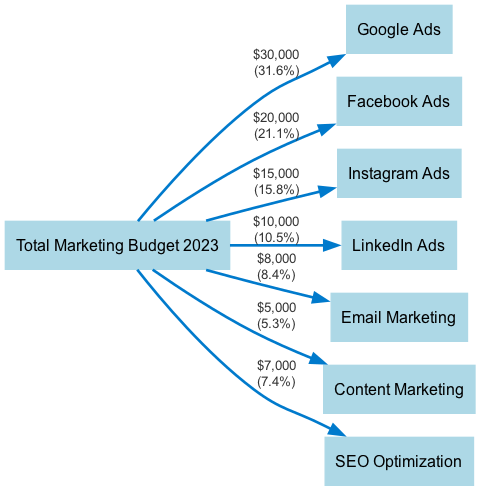What is the total marketing budget for 2023? The diagram indicates the total marketing budget at the source node "Total Marketing Budget 2023." By summing the values of all outgoing links, we find that the total is $100,000.
Answer: $100,000 Which platform receives the highest budget allocation? By examining the outgoing links from "Total Marketing Budget 2023," we see that "Google Ads" has the highest value link of $30,000.
Answer: Google Ads How much is allocated to Email Marketing? The link from "Total Marketing Budget 2023" to "Email Marketing" specifies a value of $8,000.
Answer: $8,000 What percentage of the total budget is allocated to Instagram Ads? The link to "Instagram Ads" shows a value of $15,000. To find the percentage, we calculate (15,000 / 100,000) * 100 = 15%.
Answer: 15% How does the budget for LinkedIn Ads compare to Content Marketing? The link to "LinkedIn Ads" has a value of $10,000, while the link to "Content Marketing" has a value of $5,000. Thus, LinkedIn Ads has a higher budget allocation.
Answer: Higher Which two platforms have the same total budget allocation? Looking at the allocations, "Email Marketing" and "SEO Optimization" both have allocations of $8,000 and $7,000 respectively, which are close but not the same. So, no two platforms have the same budget allocation. However, a question could involve comparisons across different campaigns.
Answer: None What is the combined allocation for Facebook Ads and Instagram Ads? The budget for Facebook Ads is $20,000 and for Instagram Ads is $15,000. Adding these values gives $20,000 + $15,000 = $35,000.
Answer: $35,000 How many platforms are included in this budget allocation? The diagram lists 7 nodes originating from the "Total Marketing Budget 2023," which represents the 7 platforms where budget allocations are made.
Answer: 7 What is the total allocation for Content Marketing and SEO Optimization combined? The value for Content Marketing is $5,000 and for SEO Optimization is $7,000. Adding these amounts together: $5,000 + $7,000 = $12,000.
Answer: $12,000 